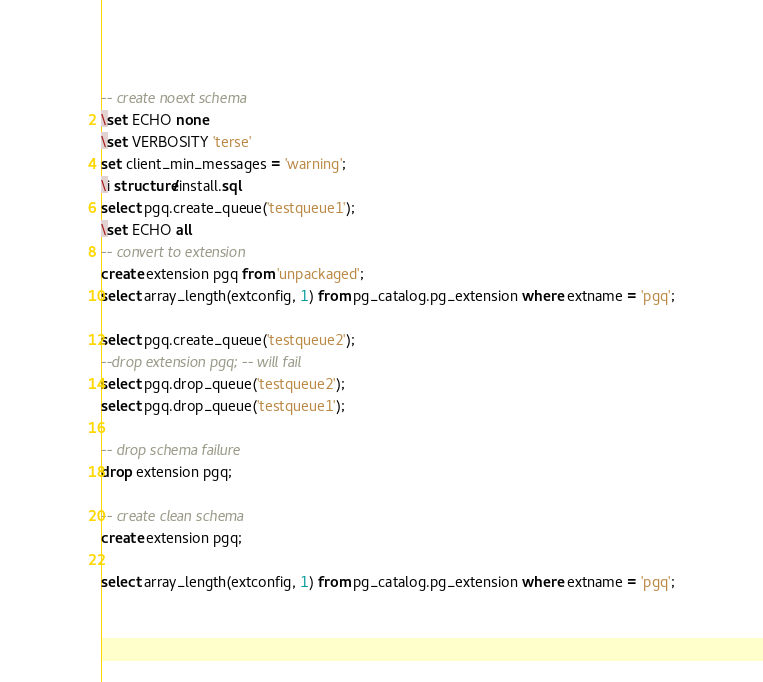<code> <loc_0><loc_0><loc_500><loc_500><_SQL_>
-- create noext schema
\set ECHO none
\set VERBOSITY 'terse'
set client_min_messages = 'warning';
\i structure/install.sql
select pgq.create_queue('testqueue1');
\set ECHO all
-- convert to extension
create extension pgq from 'unpackaged';
select array_length(extconfig, 1) from pg_catalog.pg_extension where extname = 'pgq';

select pgq.create_queue('testqueue2');
--drop extension pgq; -- will fail
select pgq.drop_queue('testqueue2');
select pgq.drop_queue('testqueue1');

-- drop schema failure
drop extension pgq;

-- create clean schema
create extension pgq;

select array_length(extconfig, 1) from pg_catalog.pg_extension where extname = 'pgq';

</code> 